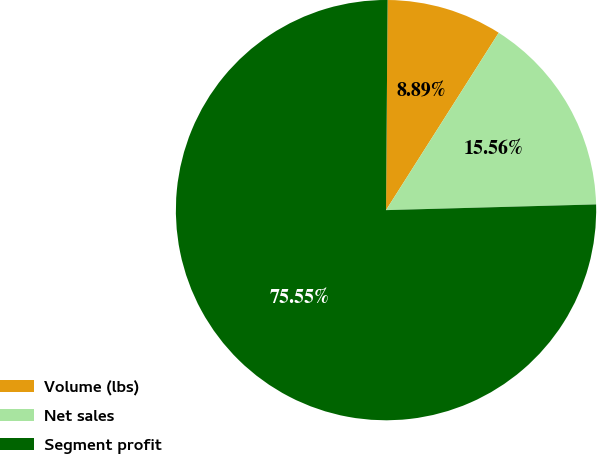Convert chart. <chart><loc_0><loc_0><loc_500><loc_500><pie_chart><fcel>Volume (lbs)<fcel>Net sales<fcel>Segment profit<nl><fcel>8.89%<fcel>15.56%<fcel>75.56%<nl></chart> 